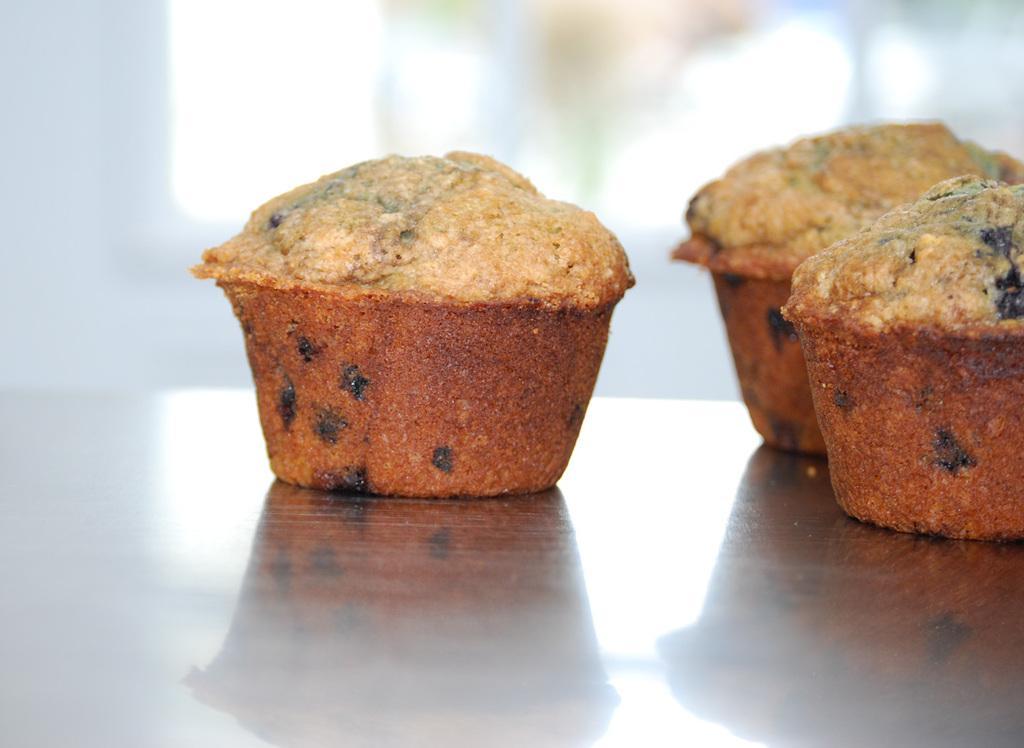Please provide a concise description of this image. In this picture we can observe some food placed on the table. The food is in brown color. There are looking like cupcakes. 